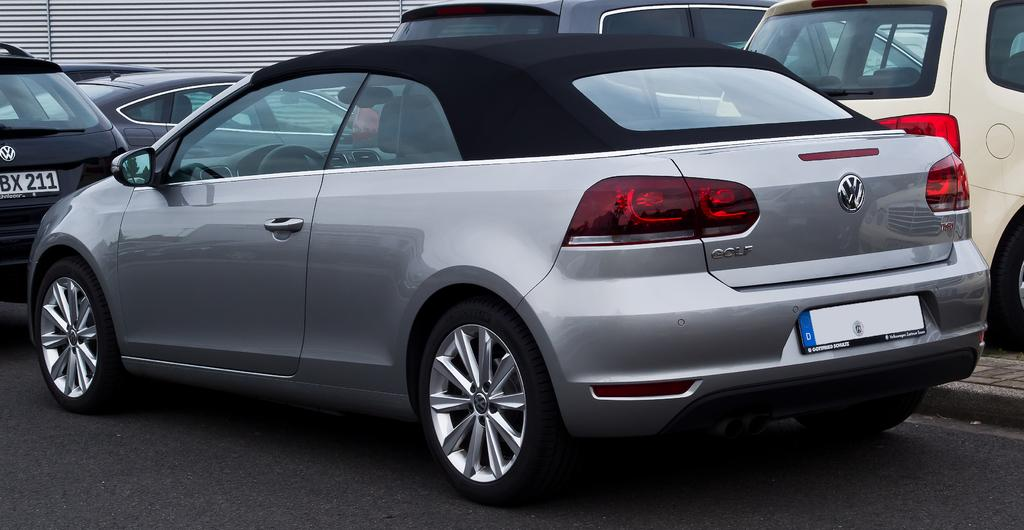What can be seen on the road in the image? There are vehicles on the road in the image. Can you describe the object visible in the background of the image? Unfortunately, the provided facts do not give enough information to describe the object in the background. What type of animals can be seen at the zoo in the image? There is no zoo present in the image, so it is not possible to determine what, if any, animals might be seen there. 